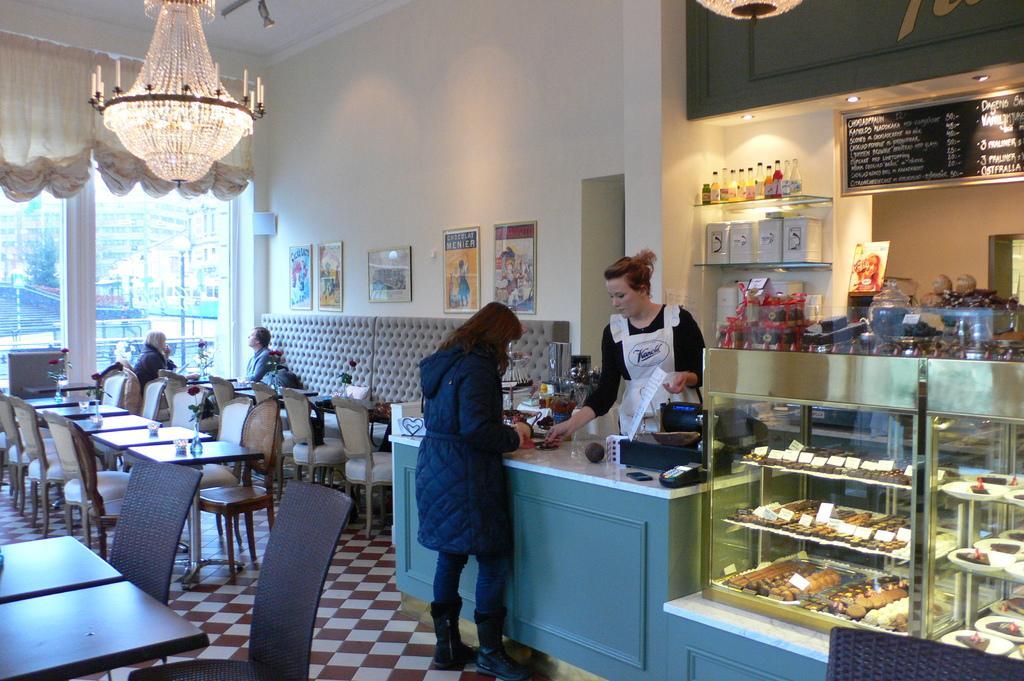In one or two sentences, can you explain what this image depicts? In this picture we can see there are two people standing and two other people sitting on chairs and in front of the people there are chairs and tables and on the table there are flower vases. In front of the two standing people there are some objects on the desk. On the right side of the people there are some food items and boards in a glass object. Behind the people there is a wall with photo frames and a board. In and on the racks there are some objects. At the top there are chandeliers. On the left side of the people there are glass windows and curtains. Behind the glass doors there are buildings, a pole and a tree. 